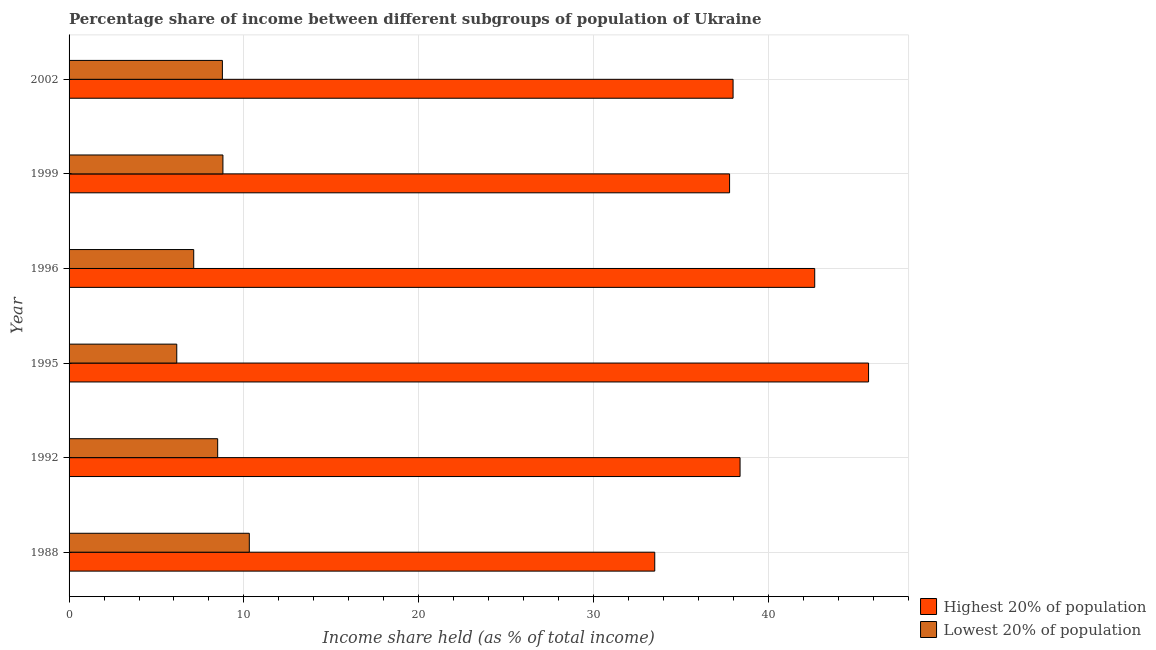How many different coloured bars are there?
Your answer should be very brief. 2. How many bars are there on the 5th tick from the top?
Keep it short and to the point. 2. How many bars are there on the 3rd tick from the bottom?
Keep it short and to the point. 2. What is the label of the 5th group of bars from the top?
Provide a succinct answer. 1992. In how many cases, is the number of bars for a given year not equal to the number of legend labels?
Provide a succinct answer. 0. What is the income share held by highest 20% of the population in 1996?
Keep it short and to the point. 42.65. Across all years, what is the maximum income share held by highest 20% of the population?
Your answer should be very brief. 45.73. Across all years, what is the minimum income share held by highest 20% of the population?
Keep it short and to the point. 33.5. In which year was the income share held by highest 20% of the population maximum?
Make the answer very short. 1995. In which year was the income share held by highest 20% of the population minimum?
Provide a succinct answer. 1988. What is the total income share held by lowest 20% of the population in the graph?
Your answer should be compact. 49.67. What is the difference between the income share held by highest 20% of the population in 1988 and that in 1999?
Your answer should be compact. -4.28. What is the difference between the income share held by highest 20% of the population in 1996 and the income share held by lowest 20% of the population in 1999?
Your answer should be very brief. 33.85. What is the average income share held by highest 20% of the population per year?
Ensure brevity in your answer.  39.34. In the year 2002, what is the difference between the income share held by lowest 20% of the population and income share held by highest 20% of the population?
Provide a short and direct response. -29.21. What is the ratio of the income share held by lowest 20% of the population in 1995 to that in 1999?
Make the answer very short. 0.7. What is the difference between the highest and the second highest income share held by highest 20% of the population?
Ensure brevity in your answer.  3.08. What is the difference between the highest and the lowest income share held by highest 20% of the population?
Offer a terse response. 12.23. Is the sum of the income share held by highest 20% of the population in 1996 and 1999 greater than the maximum income share held by lowest 20% of the population across all years?
Your response must be concise. Yes. What does the 1st bar from the top in 2002 represents?
Your answer should be very brief. Lowest 20% of population. What does the 2nd bar from the bottom in 2002 represents?
Your answer should be very brief. Lowest 20% of population. How many bars are there?
Give a very brief answer. 12. Are all the bars in the graph horizontal?
Offer a very short reply. Yes. How many years are there in the graph?
Provide a short and direct response. 6. What is the difference between two consecutive major ticks on the X-axis?
Provide a short and direct response. 10. Does the graph contain any zero values?
Your answer should be compact. No. Does the graph contain grids?
Provide a succinct answer. Yes. How are the legend labels stacked?
Your response must be concise. Vertical. What is the title of the graph?
Your answer should be very brief. Percentage share of income between different subgroups of population of Ukraine. Does "Overweight" appear as one of the legend labels in the graph?
Provide a succinct answer. No. What is the label or title of the X-axis?
Your answer should be compact. Income share held (as % of total income). What is the Income share held (as % of total income) in Highest 20% of population in 1988?
Offer a very short reply. 33.5. What is the Income share held (as % of total income) of Lowest 20% of population in 1988?
Make the answer very short. 10.31. What is the Income share held (as % of total income) in Highest 20% of population in 1992?
Provide a short and direct response. 38.38. What is the Income share held (as % of total income) of Highest 20% of population in 1995?
Offer a terse response. 45.73. What is the Income share held (as % of total income) of Lowest 20% of population in 1995?
Make the answer very short. 6.16. What is the Income share held (as % of total income) of Highest 20% of population in 1996?
Provide a succinct answer. 42.65. What is the Income share held (as % of total income) in Lowest 20% of population in 1996?
Your answer should be compact. 7.13. What is the Income share held (as % of total income) in Highest 20% of population in 1999?
Make the answer very short. 37.78. What is the Income share held (as % of total income) of Lowest 20% of population in 1999?
Your answer should be very brief. 8.8. What is the Income share held (as % of total income) in Highest 20% of population in 2002?
Provide a short and direct response. 37.98. What is the Income share held (as % of total income) of Lowest 20% of population in 2002?
Your answer should be very brief. 8.77. Across all years, what is the maximum Income share held (as % of total income) of Highest 20% of population?
Make the answer very short. 45.73. Across all years, what is the maximum Income share held (as % of total income) in Lowest 20% of population?
Offer a terse response. 10.31. Across all years, what is the minimum Income share held (as % of total income) of Highest 20% of population?
Your answer should be compact. 33.5. Across all years, what is the minimum Income share held (as % of total income) of Lowest 20% of population?
Offer a very short reply. 6.16. What is the total Income share held (as % of total income) of Highest 20% of population in the graph?
Provide a short and direct response. 236.02. What is the total Income share held (as % of total income) in Lowest 20% of population in the graph?
Keep it short and to the point. 49.67. What is the difference between the Income share held (as % of total income) in Highest 20% of population in 1988 and that in 1992?
Give a very brief answer. -4.88. What is the difference between the Income share held (as % of total income) of Lowest 20% of population in 1988 and that in 1992?
Keep it short and to the point. 1.81. What is the difference between the Income share held (as % of total income) in Highest 20% of population in 1988 and that in 1995?
Give a very brief answer. -12.23. What is the difference between the Income share held (as % of total income) of Lowest 20% of population in 1988 and that in 1995?
Provide a succinct answer. 4.15. What is the difference between the Income share held (as % of total income) in Highest 20% of population in 1988 and that in 1996?
Provide a short and direct response. -9.15. What is the difference between the Income share held (as % of total income) in Lowest 20% of population in 1988 and that in 1996?
Make the answer very short. 3.18. What is the difference between the Income share held (as % of total income) of Highest 20% of population in 1988 and that in 1999?
Your response must be concise. -4.28. What is the difference between the Income share held (as % of total income) of Lowest 20% of population in 1988 and that in 1999?
Your answer should be compact. 1.51. What is the difference between the Income share held (as % of total income) in Highest 20% of population in 1988 and that in 2002?
Give a very brief answer. -4.48. What is the difference between the Income share held (as % of total income) in Lowest 20% of population in 1988 and that in 2002?
Offer a terse response. 1.54. What is the difference between the Income share held (as % of total income) in Highest 20% of population in 1992 and that in 1995?
Your response must be concise. -7.35. What is the difference between the Income share held (as % of total income) in Lowest 20% of population in 1992 and that in 1995?
Your answer should be very brief. 2.34. What is the difference between the Income share held (as % of total income) in Highest 20% of population in 1992 and that in 1996?
Offer a very short reply. -4.27. What is the difference between the Income share held (as % of total income) in Lowest 20% of population in 1992 and that in 1996?
Your answer should be compact. 1.37. What is the difference between the Income share held (as % of total income) of Highest 20% of population in 1992 and that in 1999?
Make the answer very short. 0.6. What is the difference between the Income share held (as % of total income) of Lowest 20% of population in 1992 and that in 2002?
Make the answer very short. -0.27. What is the difference between the Income share held (as % of total income) in Highest 20% of population in 1995 and that in 1996?
Your response must be concise. 3.08. What is the difference between the Income share held (as % of total income) in Lowest 20% of population in 1995 and that in 1996?
Offer a very short reply. -0.97. What is the difference between the Income share held (as % of total income) of Highest 20% of population in 1995 and that in 1999?
Ensure brevity in your answer.  7.95. What is the difference between the Income share held (as % of total income) of Lowest 20% of population in 1995 and that in 1999?
Offer a terse response. -2.64. What is the difference between the Income share held (as % of total income) of Highest 20% of population in 1995 and that in 2002?
Offer a terse response. 7.75. What is the difference between the Income share held (as % of total income) in Lowest 20% of population in 1995 and that in 2002?
Your answer should be very brief. -2.61. What is the difference between the Income share held (as % of total income) in Highest 20% of population in 1996 and that in 1999?
Make the answer very short. 4.87. What is the difference between the Income share held (as % of total income) in Lowest 20% of population in 1996 and that in 1999?
Provide a succinct answer. -1.67. What is the difference between the Income share held (as % of total income) in Highest 20% of population in 1996 and that in 2002?
Keep it short and to the point. 4.67. What is the difference between the Income share held (as % of total income) of Lowest 20% of population in 1996 and that in 2002?
Offer a very short reply. -1.64. What is the difference between the Income share held (as % of total income) of Highest 20% of population in 1999 and that in 2002?
Your response must be concise. -0.2. What is the difference between the Income share held (as % of total income) of Highest 20% of population in 1988 and the Income share held (as % of total income) of Lowest 20% of population in 1995?
Ensure brevity in your answer.  27.34. What is the difference between the Income share held (as % of total income) of Highest 20% of population in 1988 and the Income share held (as % of total income) of Lowest 20% of population in 1996?
Provide a succinct answer. 26.37. What is the difference between the Income share held (as % of total income) in Highest 20% of population in 1988 and the Income share held (as % of total income) in Lowest 20% of population in 1999?
Keep it short and to the point. 24.7. What is the difference between the Income share held (as % of total income) in Highest 20% of population in 1988 and the Income share held (as % of total income) in Lowest 20% of population in 2002?
Offer a terse response. 24.73. What is the difference between the Income share held (as % of total income) of Highest 20% of population in 1992 and the Income share held (as % of total income) of Lowest 20% of population in 1995?
Keep it short and to the point. 32.22. What is the difference between the Income share held (as % of total income) in Highest 20% of population in 1992 and the Income share held (as % of total income) in Lowest 20% of population in 1996?
Make the answer very short. 31.25. What is the difference between the Income share held (as % of total income) of Highest 20% of population in 1992 and the Income share held (as % of total income) of Lowest 20% of population in 1999?
Make the answer very short. 29.58. What is the difference between the Income share held (as % of total income) in Highest 20% of population in 1992 and the Income share held (as % of total income) in Lowest 20% of population in 2002?
Your response must be concise. 29.61. What is the difference between the Income share held (as % of total income) in Highest 20% of population in 1995 and the Income share held (as % of total income) in Lowest 20% of population in 1996?
Offer a very short reply. 38.6. What is the difference between the Income share held (as % of total income) of Highest 20% of population in 1995 and the Income share held (as % of total income) of Lowest 20% of population in 1999?
Your answer should be compact. 36.93. What is the difference between the Income share held (as % of total income) of Highest 20% of population in 1995 and the Income share held (as % of total income) of Lowest 20% of population in 2002?
Offer a very short reply. 36.96. What is the difference between the Income share held (as % of total income) in Highest 20% of population in 1996 and the Income share held (as % of total income) in Lowest 20% of population in 1999?
Provide a short and direct response. 33.85. What is the difference between the Income share held (as % of total income) of Highest 20% of population in 1996 and the Income share held (as % of total income) of Lowest 20% of population in 2002?
Offer a very short reply. 33.88. What is the difference between the Income share held (as % of total income) in Highest 20% of population in 1999 and the Income share held (as % of total income) in Lowest 20% of population in 2002?
Keep it short and to the point. 29.01. What is the average Income share held (as % of total income) of Highest 20% of population per year?
Your response must be concise. 39.34. What is the average Income share held (as % of total income) in Lowest 20% of population per year?
Ensure brevity in your answer.  8.28. In the year 1988, what is the difference between the Income share held (as % of total income) of Highest 20% of population and Income share held (as % of total income) of Lowest 20% of population?
Give a very brief answer. 23.19. In the year 1992, what is the difference between the Income share held (as % of total income) in Highest 20% of population and Income share held (as % of total income) in Lowest 20% of population?
Offer a very short reply. 29.88. In the year 1995, what is the difference between the Income share held (as % of total income) of Highest 20% of population and Income share held (as % of total income) of Lowest 20% of population?
Keep it short and to the point. 39.57. In the year 1996, what is the difference between the Income share held (as % of total income) of Highest 20% of population and Income share held (as % of total income) of Lowest 20% of population?
Offer a very short reply. 35.52. In the year 1999, what is the difference between the Income share held (as % of total income) in Highest 20% of population and Income share held (as % of total income) in Lowest 20% of population?
Ensure brevity in your answer.  28.98. In the year 2002, what is the difference between the Income share held (as % of total income) of Highest 20% of population and Income share held (as % of total income) of Lowest 20% of population?
Your answer should be compact. 29.21. What is the ratio of the Income share held (as % of total income) in Highest 20% of population in 1988 to that in 1992?
Provide a short and direct response. 0.87. What is the ratio of the Income share held (as % of total income) in Lowest 20% of population in 1988 to that in 1992?
Offer a terse response. 1.21. What is the ratio of the Income share held (as % of total income) of Highest 20% of population in 1988 to that in 1995?
Offer a terse response. 0.73. What is the ratio of the Income share held (as % of total income) in Lowest 20% of population in 1988 to that in 1995?
Provide a succinct answer. 1.67. What is the ratio of the Income share held (as % of total income) of Highest 20% of population in 1988 to that in 1996?
Your answer should be compact. 0.79. What is the ratio of the Income share held (as % of total income) in Lowest 20% of population in 1988 to that in 1996?
Offer a very short reply. 1.45. What is the ratio of the Income share held (as % of total income) in Highest 20% of population in 1988 to that in 1999?
Your answer should be compact. 0.89. What is the ratio of the Income share held (as % of total income) in Lowest 20% of population in 1988 to that in 1999?
Your response must be concise. 1.17. What is the ratio of the Income share held (as % of total income) of Highest 20% of population in 1988 to that in 2002?
Ensure brevity in your answer.  0.88. What is the ratio of the Income share held (as % of total income) in Lowest 20% of population in 1988 to that in 2002?
Offer a very short reply. 1.18. What is the ratio of the Income share held (as % of total income) in Highest 20% of population in 1992 to that in 1995?
Your answer should be very brief. 0.84. What is the ratio of the Income share held (as % of total income) of Lowest 20% of population in 1992 to that in 1995?
Keep it short and to the point. 1.38. What is the ratio of the Income share held (as % of total income) of Highest 20% of population in 1992 to that in 1996?
Your answer should be very brief. 0.9. What is the ratio of the Income share held (as % of total income) in Lowest 20% of population in 1992 to that in 1996?
Keep it short and to the point. 1.19. What is the ratio of the Income share held (as % of total income) in Highest 20% of population in 1992 to that in 1999?
Your answer should be very brief. 1.02. What is the ratio of the Income share held (as % of total income) of Lowest 20% of population in 1992 to that in 1999?
Your answer should be very brief. 0.97. What is the ratio of the Income share held (as % of total income) in Highest 20% of population in 1992 to that in 2002?
Provide a short and direct response. 1.01. What is the ratio of the Income share held (as % of total income) in Lowest 20% of population in 1992 to that in 2002?
Offer a very short reply. 0.97. What is the ratio of the Income share held (as % of total income) of Highest 20% of population in 1995 to that in 1996?
Offer a terse response. 1.07. What is the ratio of the Income share held (as % of total income) in Lowest 20% of population in 1995 to that in 1996?
Provide a succinct answer. 0.86. What is the ratio of the Income share held (as % of total income) in Highest 20% of population in 1995 to that in 1999?
Give a very brief answer. 1.21. What is the ratio of the Income share held (as % of total income) in Highest 20% of population in 1995 to that in 2002?
Offer a very short reply. 1.2. What is the ratio of the Income share held (as % of total income) of Lowest 20% of population in 1995 to that in 2002?
Make the answer very short. 0.7. What is the ratio of the Income share held (as % of total income) of Highest 20% of population in 1996 to that in 1999?
Your answer should be very brief. 1.13. What is the ratio of the Income share held (as % of total income) of Lowest 20% of population in 1996 to that in 1999?
Your answer should be compact. 0.81. What is the ratio of the Income share held (as % of total income) of Highest 20% of population in 1996 to that in 2002?
Provide a succinct answer. 1.12. What is the ratio of the Income share held (as % of total income) of Lowest 20% of population in 1996 to that in 2002?
Ensure brevity in your answer.  0.81. What is the ratio of the Income share held (as % of total income) in Highest 20% of population in 1999 to that in 2002?
Keep it short and to the point. 0.99. What is the ratio of the Income share held (as % of total income) of Lowest 20% of population in 1999 to that in 2002?
Offer a terse response. 1. What is the difference between the highest and the second highest Income share held (as % of total income) in Highest 20% of population?
Provide a short and direct response. 3.08. What is the difference between the highest and the second highest Income share held (as % of total income) of Lowest 20% of population?
Your response must be concise. 1.51. What is the difference between the highest and the lowest Income share held (as % of total income) of Highest 20% of population?
Your response must be concise. 12.23. What is the difference between the highest and the lowest Income share held (as % of total income) of Lowest 20% of population?
Provide a short and direct response. 4.15. 